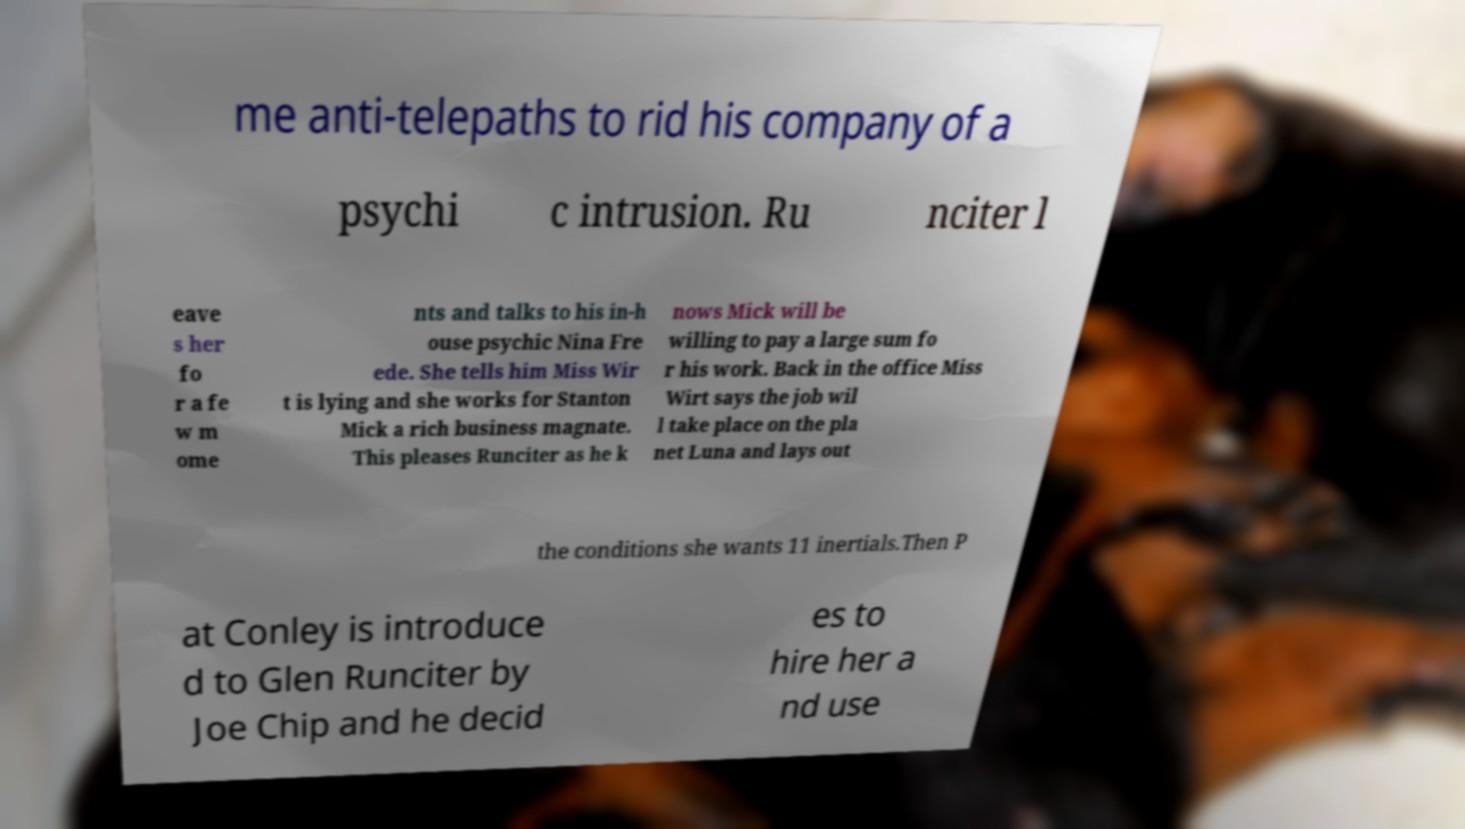Could you extract and type out the text from this image? me anti-telepaths to rid his company of a psychi c intrusion. Ru nciter l eave s her fo r a fe w m ome nts and talks to his in-h ouse psychic Nina Fre ede. She tells him Miss Wir t is lying and she works for Stanton Mick a rich business magnate. This pleases Runciter as he k nows Mick will be willing to pay a large sum fo r his work. Back in the office Miss Wirt says the job wil l take place on the pla net Luna and lays out the conditions she wants 11 inertials.Then P at Conley is introduce d to Glen Runciter by Joe Chip and he decid es to hire her a nd use 